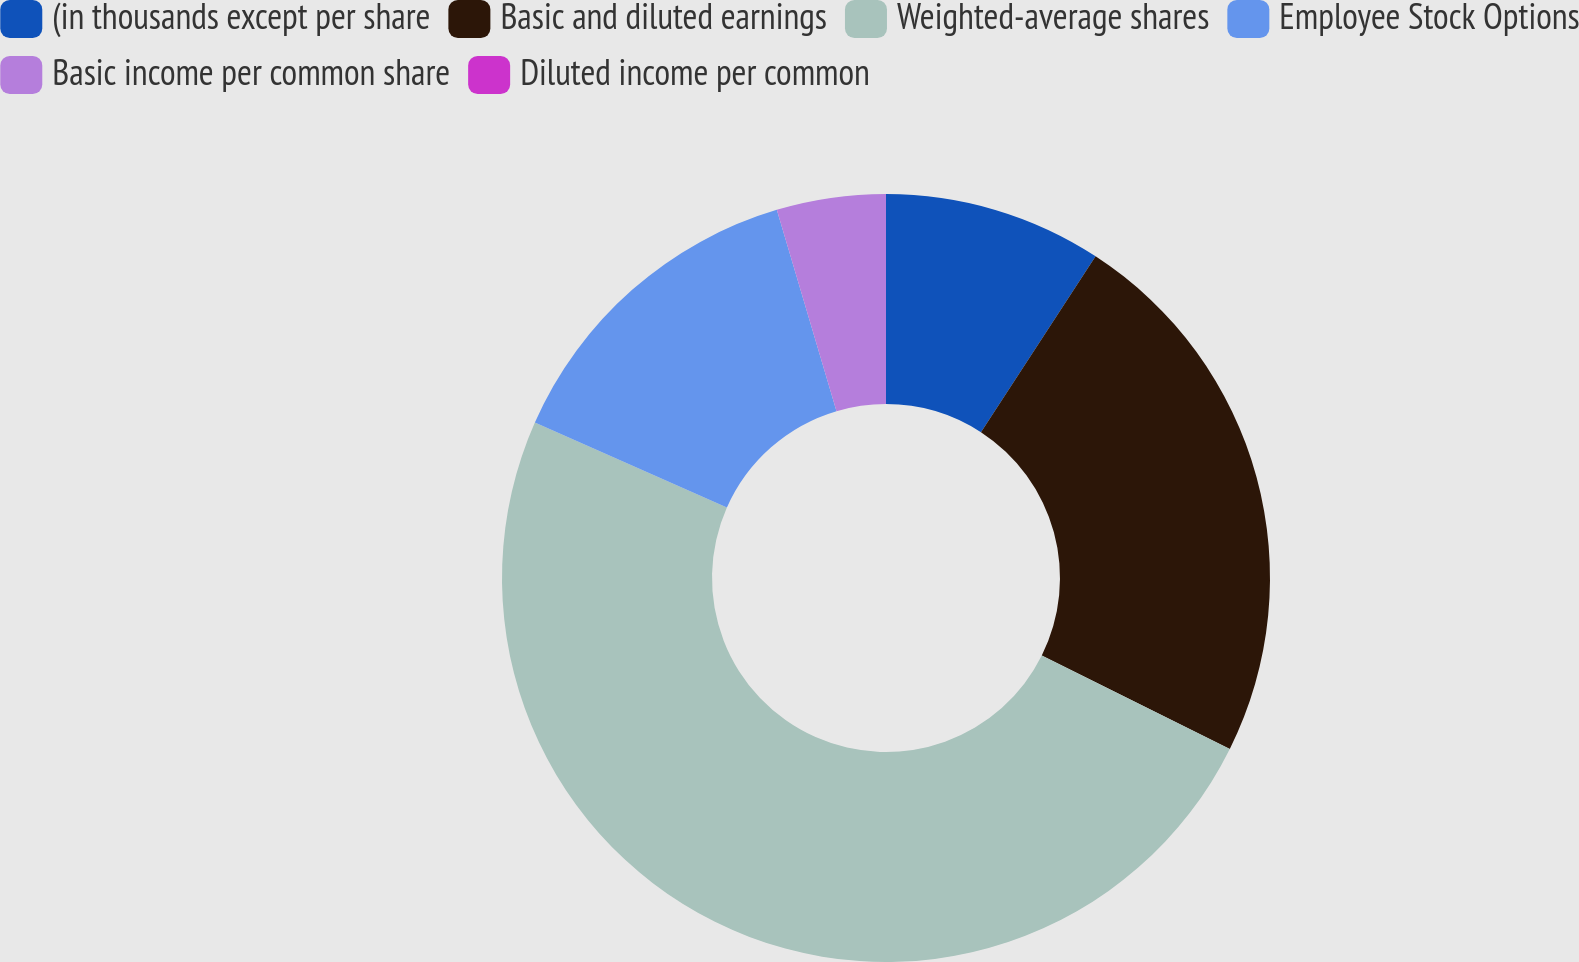Convert chart. <chart><loc_0><loc_0><loc_500><loc_500><pie_chart><fcel>(in thousands except per share<fcel>Basic and diluted earnings<fcel>Weighted-average shares<fcel>Employee Stock Options<fcel>Basic income per common share<fcel>Diluted income per common<nl><fcel>9.19%<fcel>23.16%<fcel>49.29%<fcel>13.78%<fcel>4.59%<fcel>0.0%<nl></chart> 